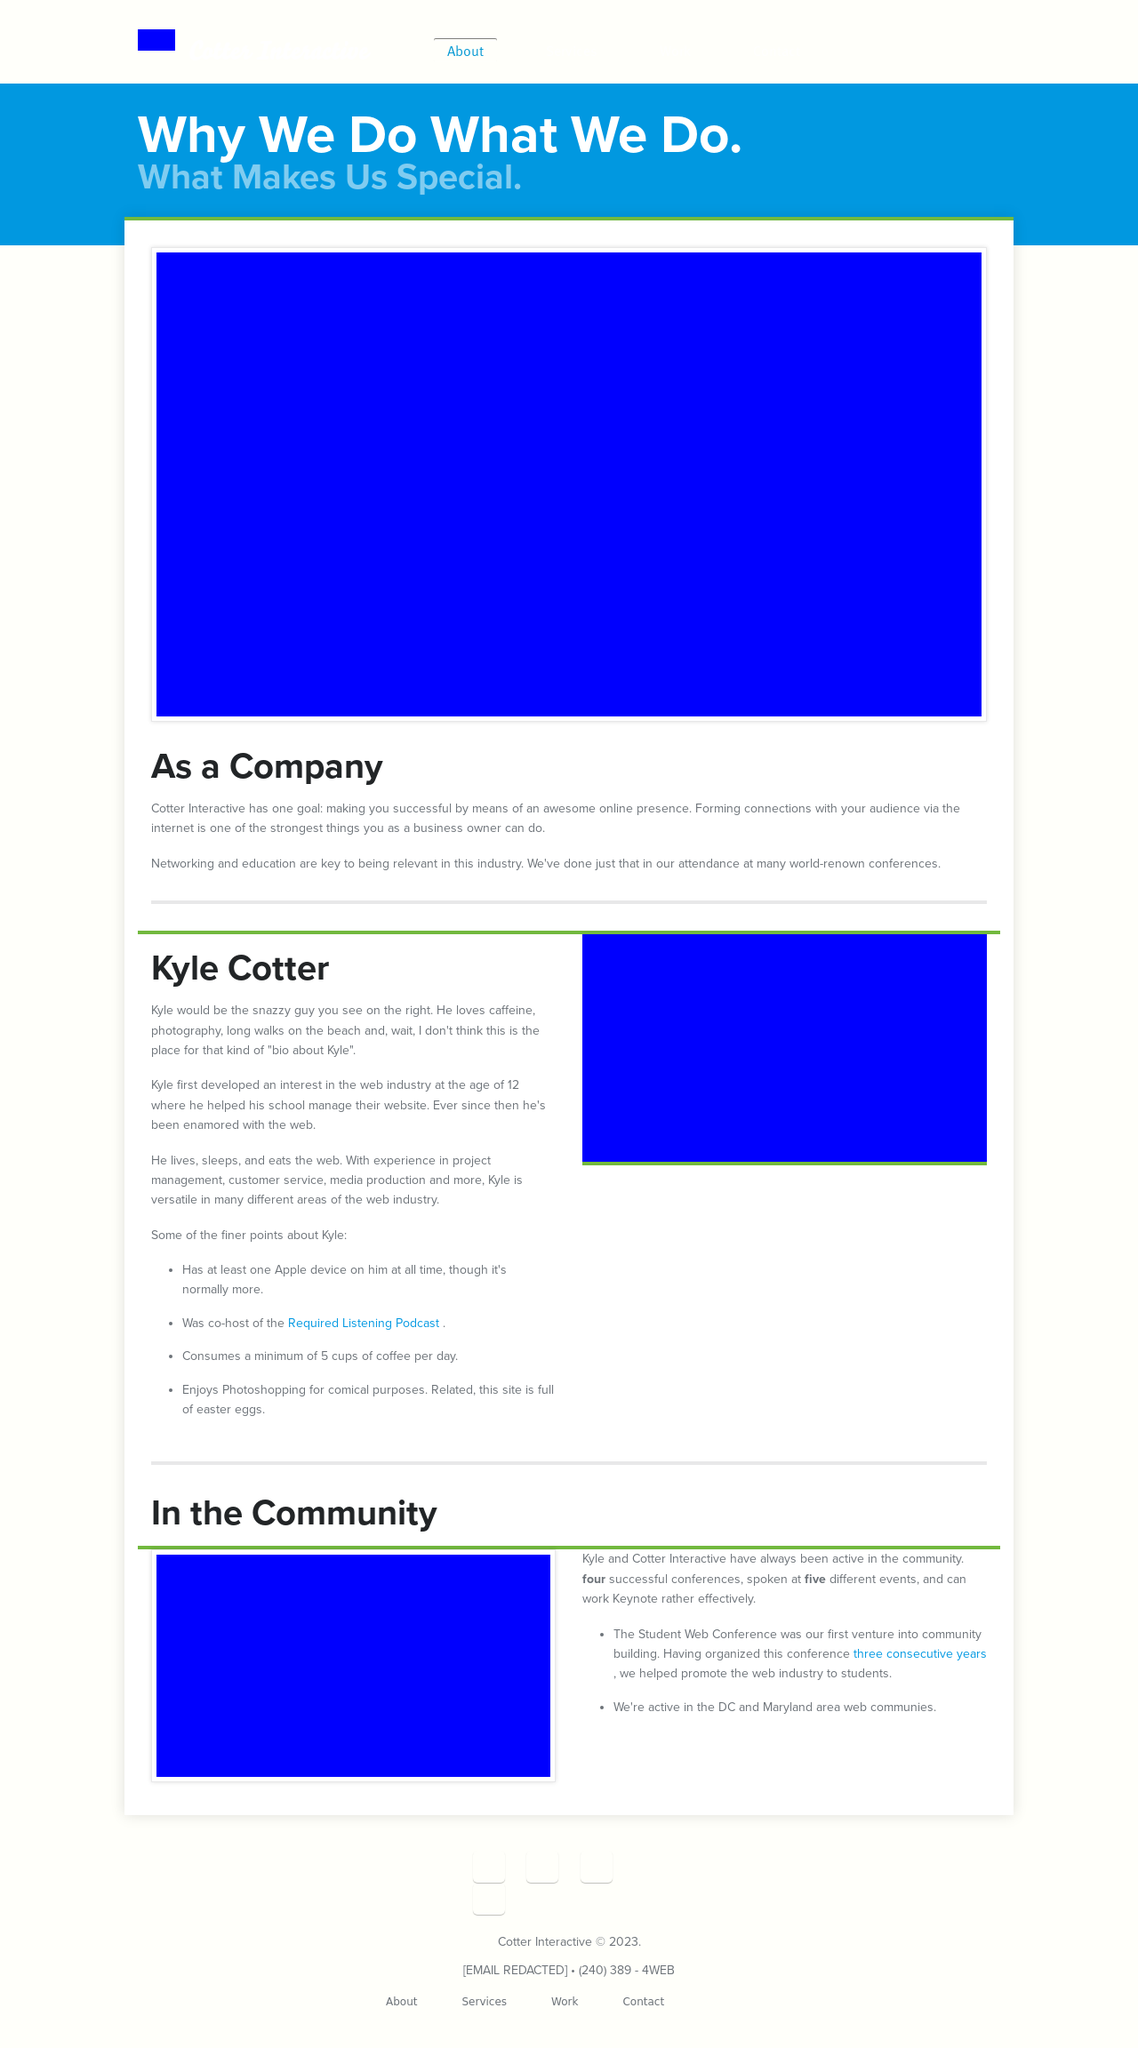What features or elements make this website visually appealing? The visual appeal of the website can be attributed to its clean layout, thoughtful use of whitespace, and modern typography. The use of large, bold text for headings paired with concise descriptions makes it easy to read and engaging. The color scheme is simple yet effective, providing a professional and sleek look. Additionally, quality images seem to be used, which enhance the engagement by visually representing the content. 